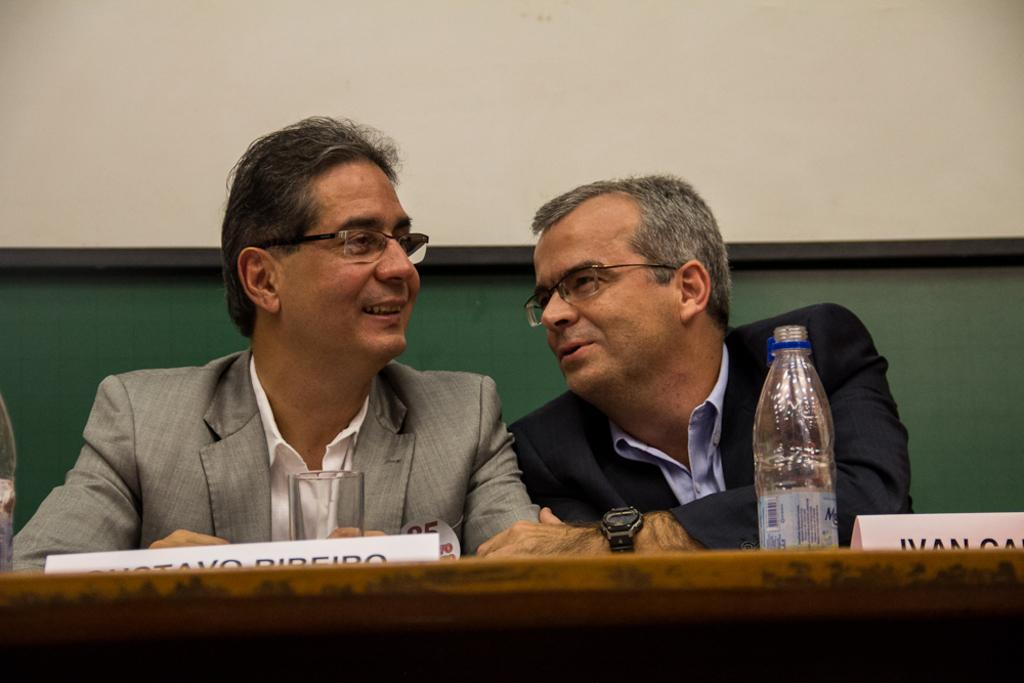How many people are in the image? There are two persons in the image. What are the persons doing in the image? The persons are sitting on chairs and smiling. What is on the table in the image? There is a bottle, a glass, and a name board on the glass on the table. What can be seen in the background of the image? There is a wall and a board in the background of the image. What type of tent can be seen in the image? There is no tent present in the image. How does the beginner use the scarf in the image? There is no beginner or scarf present in the image. 